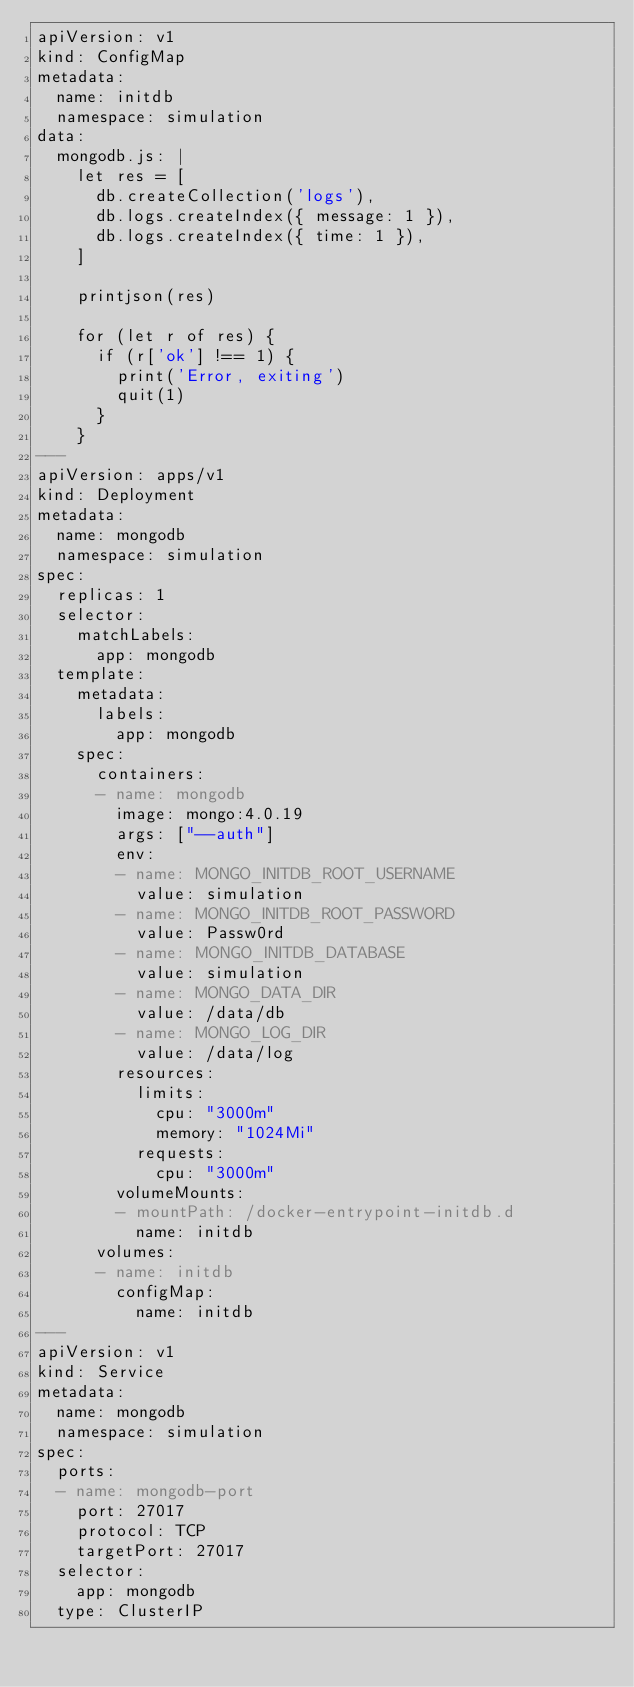Convert code to text. <code><loc_0><loc_0><loc_500><loc_500><_YAML_>apiVersion: v1
kind: ConfigMap
metadata:
  name: initdb
  namespace: simulation
data:
  mongodb.js: |
    let res = [
      db.createCollection('logs'),
      db.logs.createIndex({ message: 1 }),
      db.logs.createIndex({ time: 1 }),
    ]

    printjson(res)

    for (let r of res) {
      if (r['ok'] !== 1) {
        print('Error, exiting')
        quit(1)
      }
    }
---
apiVersion: apps/v1
kind: Deployment
metadata:
  name: mongodb
  namespace: simulation
spec:
  replicas: 1
  selector:
    matchLabels:
      app: mongodb
  template:
    metadata:
      labels:
        app: mongodb
    spec:
      containers:
      - name: mongodb
        image: mongo:4.0.19
        args: ["--auth"]
        env:
        - name: MONGO_INITDB_ROOT_USERNAME
          value: simulation
        - name: MONGO_INITDB_ROOT_PASSWORD
          value: Passw0rd
        - name: MONGO_INITDB_DATABASE
          value: simulation
        - name: MONGO_DATA_DIR
          value: /data/db
        - name: MONGO_LOG_DIR
          value: /data/log
        resources:
          limits:
            cpu: "3000m"
            memory: "1024Mi"
          requests:
            cpu: "3000m"
        volumeMounts:
        - mountPath: /docker-entrypoint-initdb.d
          name: initdb
      volumes:
      - name: initdb
        configMap:
          name: initdb
---
apiVersion: v1
kind: Service
metadata:
  name: mongodb
  namespace: simulation
spec:
  ports:
  - name: mongodb-port
    port: 27017
    protocol: TCP
    targetPort: 27017
  selector:
    app: mongodb
  type: ClusterIP
</code> 